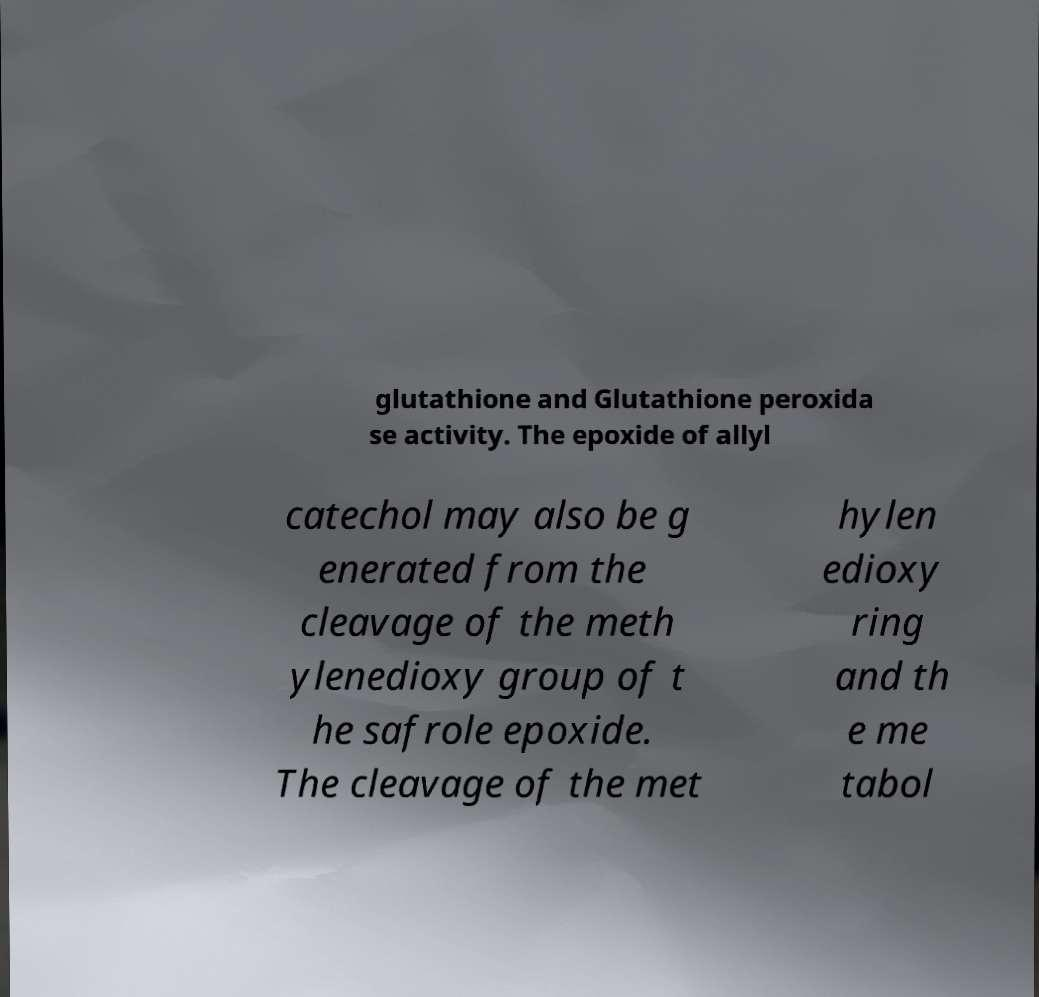I need the written content from this picture converted into text. Can you do that? glutathione and Glutathione peroxida se activity. The epoxide of allyl catechol may also be g enerated from the cleavage of the meth ylenedioxy group of t he safrole epoxide. The cleavage of the met hylen edioxy ring and th e me tabol 